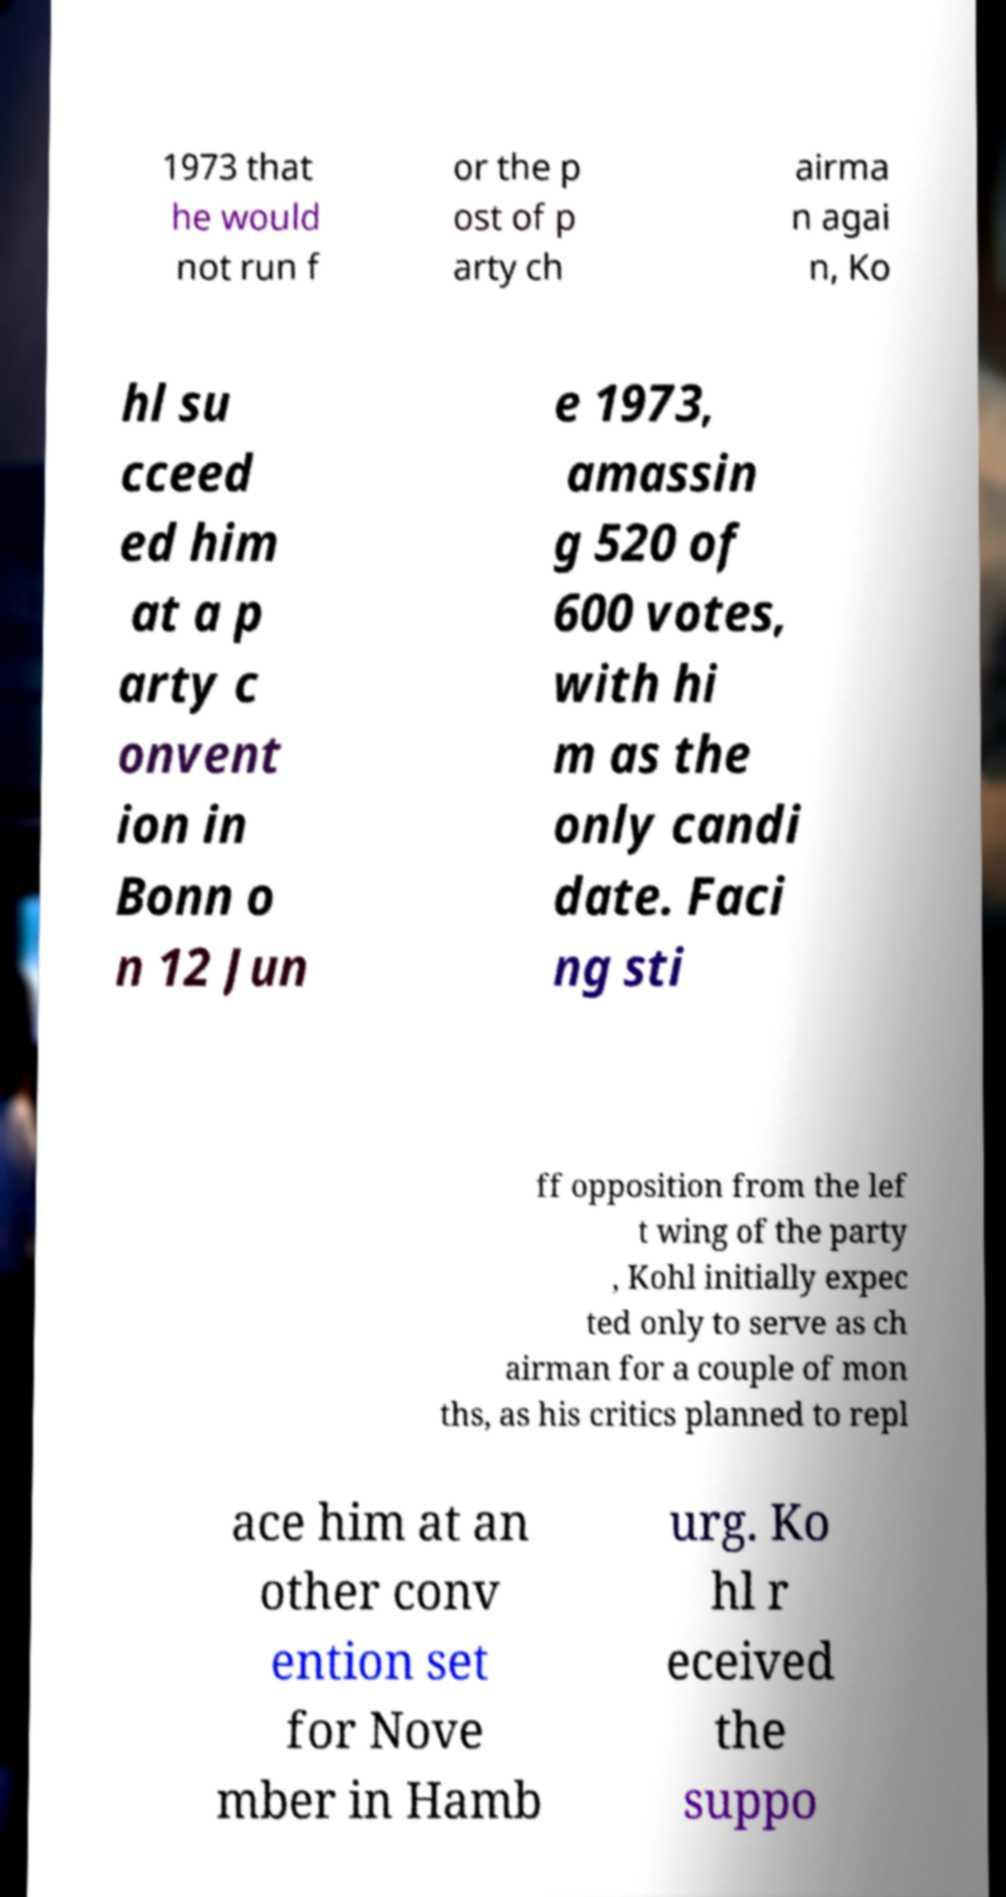Can you read and provide the text displayed in the image?This photo seems to have some interesting text. Can you extract and type it out for me? 1973 that he would not run f or the p ost of p arty ch airma n agai n, Ko hl su cceed ed him at a p arty c onvent ion in Bonn o n 12 Jun e 1973, amassin g 520 of 600 votes, with hi m as the only candi date. Faci ng sti ff opposition from the lef t wing of the party , Kohl initially expec ted only to serve as ch airman for a couple of mon ths, as his critics planned to repl ace him at an other conv ention set for Nove mber in Hamb urg. Ko hl r eceived the suppo 